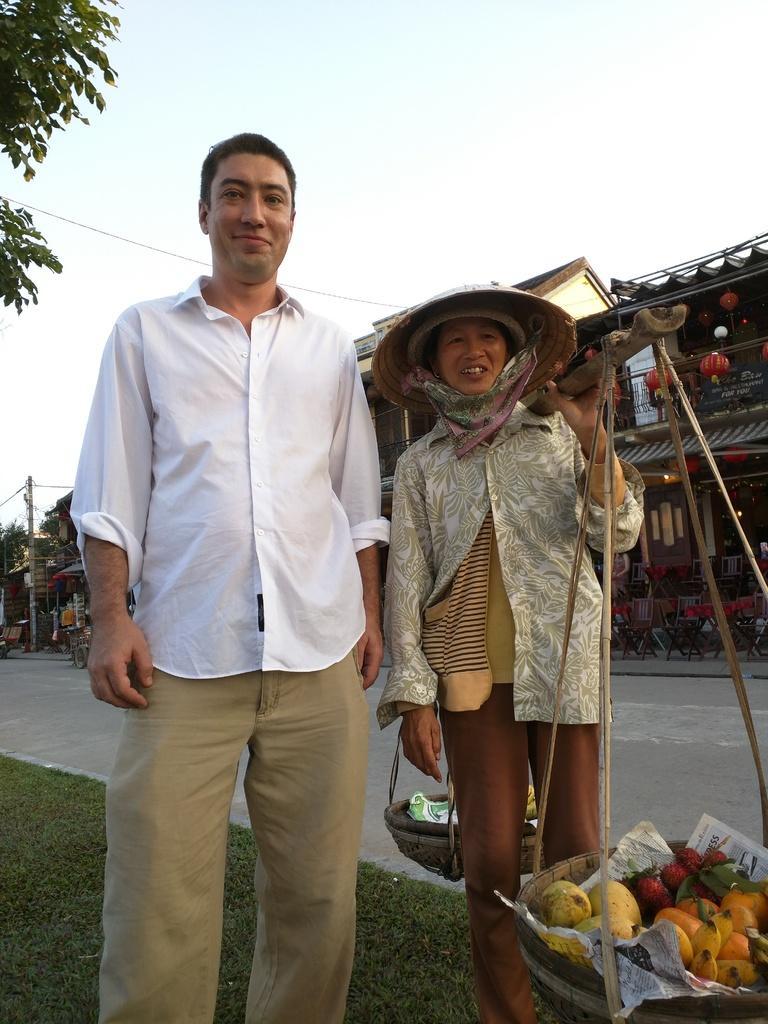In one or two sentences, can you explain what this image depicts? In this picture a man and a woman standing, Woman holding a stick on the shoulder with couple of baskets hanging to the stick and i see fruits in one basket and she wore a hat on her head and on the left side i see trees and a building on the right side and few vehicles parked and a cloudy sky on the top and grass on the ground. 